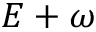<formula> <loc_0><loc_0><loc_500><loc_500>E + \omega</formula> 